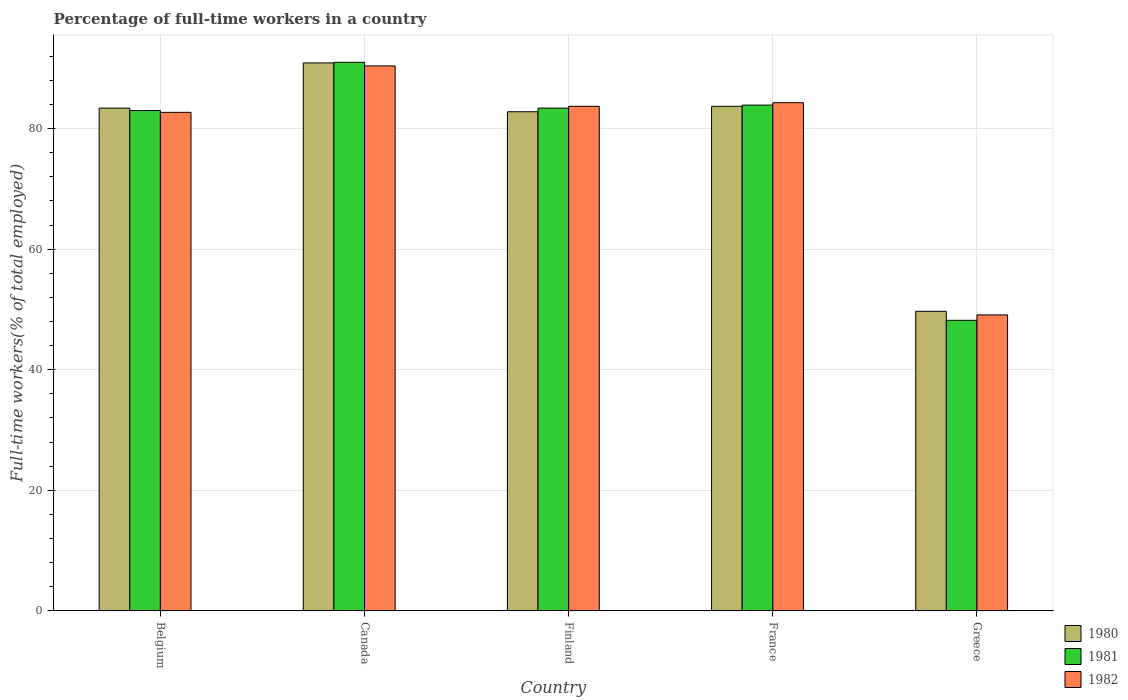How many different coloured bars are there?
Offer a very short reply. 3. Are the number of bars per tick equal to the number of legend labels?
Your response must be concise. Yes. How many bars are there on the 5th tick from the right?
Ensure brevity in your answer.  3. In how many cases, is the number of bars for a given country not equal to the number of legend labels?
Offer a terse response. 0. What is the percentage of full-time workers in 1981 in France?
Ensure brevity in your answer.  83.9. Across all countries, what is the maximum percentage of full-time workers in 1982?
Ensure brevity in your answer.  90.4. Across all countries, what is the minimum percentage of full-time workers in 1981?
Give a very brief answer. 48.2. In which country was the percentage of full-time workers in 1981 maximum?
Offer a very short reply. Canada. What is the total percentage of full-time workers in 1981 in the graph?
Make the answer very short. 389.5. What is the difference between the percentage of full-time workers in 1980 in Belgium and that in Finland?
Make the answer very short. 0.6. What is the difference between the percentage of full-time workers in 1980 in Belgium and the percentage of full-time workers in 1981 in Canada?
Give a very brief answer. -7.6. What is the average percentage of full-time workers in 1981 per country?
Offer a terse response. 77.9. What is the difference between the percentage of full-time workers of/in 1981 and percentage of full-time workers of/in 1982 in France?
Provide a succinct answer. -0.4. What is the ratio of the percentage of full-time workers in 1981 in Canada to that in Finland?
Keep it short and to the point. 1.09. Is the difference between the percentage of full-time workers in 1981 in France and Greece greater than the difference between the percentage of full-time workers in 1982 in France and Greece?
Your answer should be compact. Yes. What is the difference between the highest and the second highest percentage of full-time workers in 1982?
Keep it short and to the point. 6.7. What is the difference between the highest and the lowest percentage of full-time workers in 1980?
Your answer should be compact. 41.2. In how many countries, is the percentage of full-time workers in 1980 greater than the average percentage of full-time workers in 1980 taken over all countries?
Your answer should be compact. 4. Is the sum of the percentage of full-time workers in 1980 in Belgium and Canada greater than the maximum percentage of full-time workers in 1981 across all countries?
Offer a terse response. Yes. How many bars are there?
Provide a succinct answer. 15. Are all the bars in the graph horizontal?
Keep it short and to the point. No. How many countries are there in the graph?
Provide a short and direct response. 5. What is the difference between two consecutive major ticks on the Y-axis?
Offer a very short reply. 20. Does the graph contain any zero values?
Ensure brevity in your answer.  No. Where does the legend appear in the graph?
Your answer should be compact. Bottom right. What is the title of the graph?
Provide a succinct answer. Percentage of full-time workers in a country. What is the label or title of the Y-axis?
Ensure brevity in your answer.  Full-time workers(% of total employed). What is the Full-time workers(% of total employed) of 1980 in Belgium?
Provide a succinct answer. 83.4. What is the Full-time workers(% of total employed) of 1981 in Belgium?
Make the answer very short. 83. What is the Full-time workers(% of total employed) of 1982 in Belgium?
Offer a terse response. 82.7. What is the Full-time workers(% of total employed) of 1980 in Canada?
Provide a succinct answer. 90.9. What is the Full-time workers(% of total employed) in 1981 in Canada?
Your response must be concise. 91. What is the Full-time workers(% of total employed) in 1982 in Canada?
Keep it short and to the point. 90.4. What is the Full-time workers(% of total employed) in 1980 in Finland?
Your response must be concise. 82.8. What is the Full-time workers(% of total employed) of 1981 in Finland?
Your response must be concise. 83.4. What is the Full-time workers(% of total employed) in 1982 in Finland?
Offer a very short reply. 83.7. What is the Full-time workers(% of total employed) in 1980 in France?
Give a very brief answer. 83.7. What is the Full-time workers(% of total employed) of 1981 in France?
Make the answer very short. 83.9. What is the Full-time workers(% of total employed) of 1982 in France?
Your answer should be compact. 84.3. What is the Full-time workers(% of total employed) of 1980 in Greece?
Your answer should be compact. 49.7. What is the Full-time workers(% of total employed) in 1981 in Greece?
Provide a short and direct response. 48.2. What is the Full-time workers(% of total employed) of 1982 in Greece?
Your response must be concise. 49.1. Across all countries, what is the maximum Full-time workers(% of total employed) of 1980?
Make the answer very short. 90.9. Across all countries, what is the maximum Full-time workers(% of total employed) of 1981?
Make the answer very short. 91. Across all countries, what is the maximum Full-time workers(% of total employed) in 1982?
Give a very brief answer. 90.4. Across all countries, what is the minimum Full-time workers(% of total employed) of 1980?
Your response must be concise. 49.7. Across all countries, what is the minimum Full-time workers(% of total employed) of 1981?
Make the answer very short. 48.2. Across all countries, what is the minimum Full-time workers(% of total employed) in 1982?
Ensure brevity in your answer.  49.1. What is the total Full-time workers(% of total employed) of 1980 in the graph?
Offer a terse response. 390.5. What is the total Full-time workers(% of total employed) of 1981 in the graph?
Make the answer very short. 389.5. What is the total Full-time workers(% of total employed) in 1982 in the graph?
Give a very brief answer. 390.2. What is the difference between the Full-time workers(% of total employed) in 1980 in Belgium and that in Canada?
Keep it short and to the point. -7.5. What is the difference between the Full-time workers(% of total employed) in 1982 in Belgium and that in Canada?
Provide a short and direct response. -7.7. What is the difference between the Full-time workers(% of total employed) in 1980 in Belgium and that in Finland?
Offer a very short reply. 0.6. What is the difference between the Full-time workers(% of total employed) in 1981 in Belgium and that in Finland?
Ensure brevity in your answer.  -0.4. What is the difference between the Full-time workers(% of total employed) of 1982 in Belgium and that in Finland?
Offer a very short reply. -1. What is the difference between the Full-time workers(% of total employed) in 1980 in Belgium and that in France?
Give a very brief answer. -0.3. What is the difference between the Full-time workers(% of total employed) in 1982 in Belgium and that in France?
Offer a terse response. -1.6. What is the difference between the Full-time workers(% of total employed) in 1980 in Belgium and that in Greece?
Provide a short and direct response. 33.7. What is the difference between the Full-time workers(% of total employed) in 1981 in Belgium and that in Greece?
Offer a very short reply. 34.8. What is the difference between the Full-time workers(% of total employed) in 1982 in Belgium and that in Greece?
Your answer should be very brief. 33.6. What is the difference between the Full-time workers(% of total employed) of 1980 in Canada and that in Finland?
Provide a succinct answer. 8.1. What is the difference between the Full-time workers(% of total employed) of 1981 in Canada and that in Finland?
Give a very brief answer. 7.6. What is the difference between the Full-time workers(% of total employed) in 1981 in Canada and that in France?
Provide a short and direct response. 7.1. What is the difference between the Full-time workers(% of total employed) of 1982 in Canada and that in France?
Your response must be concise. 6.1. What is the difference between the Full-time workers(% of total employed) in 1980 in Canada and that in Greece?
Make the answer very short. 41.2. What is the difference between the Full-time workers(% of total employed) in 1981 in Canada and that in Greece?
Offer a very short reply. 42.8. What is the difference between the Full-time workers(% of total employed) of 1982 in Canada and that in Greece?
Make the answer very short. 41.3. What is the difference between the Full-time workers(% of total employed) of 1981 in Finland and that in France?
Offer a very short reply. -0.5. What is the difference between the Full-time workers(% of total employed) in 1980 in Finland and that in Greece?
Your answer should be very brief. 33.1. What is the difference between the Full-time workers(% of total employed) in 1981 in Finland and that in Greece?
Keep it short and to the point. 35.2. What is the difference between the Full-time workers(% of total employed) in 1982 in Finland and that in Greece?
Ensure brevity in your answer.  34.6. What is the difference between the Full-time workers(% of total employed) in 1980 in France and that in Greece?
Ensure brevity in your answer.  34. What is the difference between the Full-time workers(% of total employed) in 1981 in France and that in Greece?
Ensure brevity in your answer.  35.7. What is the difference between the Full-time workers(% of total employed) of 1982 in France and that in Greece?
Offer a very short reply. 35.2. What is the difference between the Full-time workers(% of total employed) in 1980 in Belgium and the Full-time workers(% of total employed) in 1982 in Canada?
Provide a succinct answer. -7. What is the difference between the Full-time workers(% of total employed) of 1980 in Belgium and the Full-time workers(% of total employed) of 1982 in Finland?
Provide a short and direct response. -0.3. What is the difference between the Full-time workers(% of total employed) in 1981 in Belgium and the Full-time workers(% of total employed) in 1982 in Finland?
Ensure brevity in your answer.  -0.7. What is the difference between the Full-time workers(% of total employed) of 1980 in Belgium and the Full-time workers(% of total employed) of 1981 in France?
Your answer should be very brief. -0.5. What is the difference between the Full-time workers(% of total employed) of 1981 in Belgium and the Full-time workers(% of total employed) of 1982 in France?
Make the answer very short. -1.3. What is the difference between the Full-time workers(% of total employed) of 1980 in Belgium and the Full-time workers(% of total employed) of 1981 in Greece?
Give a very brief answer. 35.2. What is the difference between the Full-time workers(% of total employed) in 1980 in Belgium and the Full-time workers(% of total employed) in 1982 in Greece?
Make the answer very short. 34.3. What is the difference between the Full-time workers(% of total employed) in 1981 in Belgium and the Full-time workers(% of total employed) in 1982 in Greece?
Provide a succinct answer. 33.9. What is the difference between the Full-time workers(% of total employed) of 1980 in Canada and the Full-time workers(% of total employed) of 1981 in Finland?
Your answer should be very brief. 7.5. What is the difference between the Full-time workers(% of total employed) in 1981 in Canada and the Full-time workers(% of total employed) in 1982 in Finland?
Keep it short and to the point. 7.3. What is the difference between the Full-time workers(% of total employed) in 1980 in Canada and the Full-time workers(% of total employed) in 1982 in France?
Offer a very short reply. 6.6. What is the difference between the Full-time workers(% of total employed) in 1981 in Canada and the Full-time workers(% of total employed) in 1982 in France?
Ensure brevity in your answer.  6.7. What is the difference between the Full-time workers(% of total employed) in 1980 in Canada and the Full-time workers(% of total employed) in 1981 in Greece?
Provide a succinct answer. 42.7. What is the difference between the Full-time workers(% of total employed) of 1980 in Canada and the Full-time workers(% of total employed) of 1982 in Greece?
Your response must be concise. 41.8. What is the difference between the Full-time workers(% of total employed) in 1981 in Canada and the Full-time workers(% of total employed) in 1982 in Greece?
Offer a very short reply. 41.9. What is the difference between the Full-time workers(% of total employed) of 1980 in Finland and the Full-time workers(% of total employed) of 1981 in France?
Provide a short and direct response. -1.1. What is the difference between the Full-time workers(% of total employed) of 1981 in Finland and the Full-time workers(% of total employed) of 1982 in France?
Your answer should be very brief. -0.9. What is the difference between the Full-time workers(% of total employed) in 1980 in Finland and the Full-time workers(% of total employed) in 1981 in Greece?
Your answer should be compact. 34.6. What is the difference between the Full-time workers(% of total employed) in 1980 in Finland and the Full-time workers(% of total employed) in 1982 in Greece?
Your answer should be very brief. 33.7. What is the difference between the Full-time workers(% of total employed) of 1981 in Finland and the Full-time workers(% of total employed) of 1982 in Greece?
Offer a very short reply. 34.3. What is the difference between the Full-time workers(% of total employed) of 1980 in France and the Full-time workers(% of total employed) of 1981 in Greece?
Your response must be concise. 35.5. What is the difference between the Full-time workers(% of total employed) in 1980 in France and the Full-time workers(% of total employed) in 1982 in Greece?
Provide a short and direct response. 34.6. What is the difference between the Full-time workers(% of total employed) in 1981 in France and the Full-time workers(% of total employed) in 1982 in Greece?
Provide a short and direct response. 34.8. What is the average Full-time workers(% of total employed) in 1980 per country?
Provide a short and direct response. 78.1. What is the average Full-time workers(% of total employed) in 1981 per country?
Your answer should be very brief. 77.9. What is the average Full-time workers(% of total employed) in 1982 per country?
Your response must be concise. 78.04. What is the difference between the Full-time workers(% of total employed) in 1980 and Full-time workers(% of total employed) in 1982 in Belgium?
Make the answer very short. 0.7. What is the difference between the Full-time workers(% of total employed) in 1980 and Full-time workers(% of total employed) in 1982 in Canada?
Your answer should be compact. 0.5. What is the difference between the Full-time workers(% of total employed) of 1980 and Full-time workers(% of total employed) of 1981 in Finland?
Your answer should be compact. -0.6. What is the difference between the Full-time workers(% of total employed) in 1980 and Full-time workers(% of total employed) in 1982 in Finland?
Your answer should be very brief. -0.9. What is the difference between the Full-time workers(% of total employed) in 1980 and Full-time workers(% of total employed) in 1982 in France?
Give a very brief answer. -0.6. What is the difference between the Full-time workers(% of total employed) of 1980 and Full-time workers(% of total employed) of 1981 in Greece?
Your response must be concise. 1.5. What is the difference between the Full-time workers(% of total employed) in 1981 and Full-time workers(% of total employed) in 1982 in Greece?
Ensure brevity in your answer.  -0.9. What is the ratio of the Full-time workers(% of total employed) of 1980 in Belgium to that in Canada?
Your answer should be compact. 0.92. What is the ratio of the Full-time workers(% of total employed) in 1981 in Belgium to that in Canada?
Ensure brevity in your answer.  0.91. What is the ratio of the Full-time workers(% of total employed) in 1982 in Belgium to that in Canada?
Your response must be concise. 0.91. What is the ratio of the Full-time workers(% of total employed) of 1981 in Belgium to that in Finland?
Ensure brevity in your answer.  1. What is the ratio of the Full-time workers(% of total employed) in 1981 in Belgium to that in France?
Provide a short and direct response. 0.99. What is the ratio of the Full-time workers(% of total employed) of 1982 in Belgium to that in France?
Your answer should be very brief. 0.98. What is the ratio of the Full-time workers(% of total employed) in 1980 in Belgium to that in Greece?
Give a very brief answer. 1.68. What is the ratio of the Full-time workers(% of total employed) in 1981 in Belgium to that in Greece?
Offer a terse response. 1.72. What is the ratio of the Full-time workers(% of total employed) in 1982 in Belgium to that in Greece?
Offer a very short reply. 1.68. What is the ratio of the Full-time workers(% of total employed) in 1980 in Canada to that in Finland?
Offer a terse response. 1.1. What is the ratio of the Full-time workers(% of total employed) of 1981 in Canada to that in Finland?
Give a very brief answer. 1.09. What is the ratio of the Full-time workers(% of total employed) in 1980 in Canada to that in France?
Your response must be concise. 1.09. What is the ratio of the Full-time workers(% of total employed) of 1981 in Canada to that in France?
Keep it short and to the point. 1.08. What is the ratio of the Full-time workers(% of total employed) of 1982 in Canada to that in France?
Your answer should be very brief. 1.07. What is the ratio of the Full-time workers(% of total employed) of 1980 in Canada to that in Greece?
Give a very brief answer. 1.83. What is the ratio of the Full-time workers(% of total employed) in 1981 in Canada to that in Greece?
Ensure brevity in your answer.  1.89. What is the ratio of the Full-time workers(% of total employed) in 1982 in Canada to that in Greece?
Ensure brevity in your answer.  1.84. What is the ratio of the Full-time workers(% of total employed) in 1980 in Finland to that in Greece?
Your answer should be compact. 1.67. What is the ratio of the Full-time workers(% of total employed) in 1981 in Finland to that in Greece?
Your answer should be very brief. 1.73. What is the ratio of the Full-time workers(% of total employed) of 1982 in Finland to that in Greece?
Provide a succinct answer. 1.7. What is the ratio of the Full-time workers(% of total employed) of 1980 in France to that in Greece?
Provide a short and direct response. 1.68. What is the ratio of the Full-time workers(% of total employed) of 1981 in France to that in Greece?
Keep it short and to the point. 1.74. What is the ratio of the Full-time workers(% of total employed) in 1982 in France to that in Greece?
Offer a very short reply. 1.72. What is the difference between the highest and the second highest Full-time workers(% of total employed) in 1980?
Your answer should be compact. 7.2. What is the difference between the highest and the second highest Full-time workers(% of total employed) in 1981?
Keep it short and to the point. 7.1. What is the difference between the highest and the lowest Full-time workers(% of total employed) of 1980?
Ensure brevity in your answer.  41.2. What is the difference between the highest and the lowest Full-time workers(% of total employed) in 1981?
Give a very brief answer. 42.8. What is the difference between the highest and the lowest Full-time workers(% of total employed) in 1982?
Your response must be concise. 41.3. 